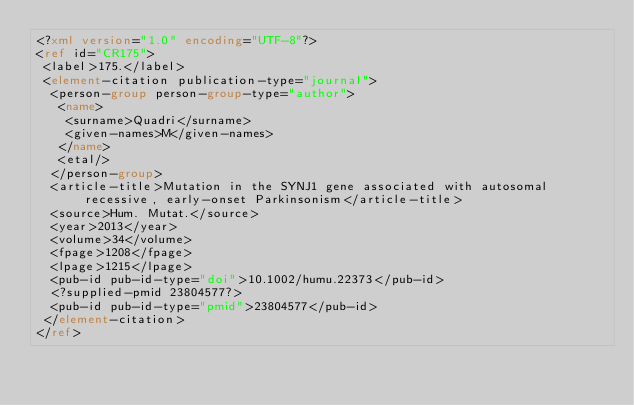Convert code to text. <code><loc_0><loc_0><loc_500><loc_500><_XML_><?xml version="1.0" encoding="UTF-8"?>
<ref id="CR175">
 <label>175.</label>
 <element-citation publication-type="journal">
  <person-group person-group-type="author">
   <name>
    <surname>Quadri</surname>
    <given-names>M</given-names>
   </name>
   <etal/>
  </person-group>
  <article-title>Mutation in the SYNJ1 gene associated with autosomal recessive, early-onset Parkinsonism</article-title>
  <source>Hum. Mutat.</source>
  <year>2013</year>
  <volume>34</volume>
  <fpage>1208</fpage>
  <lpage>1215</lpage>
  <pub-id pub-id-type="doi">10.1002/humu.22373</pub-id>
  <?supplied-pmid 23804577?>
  <pub-id pub-id-type="pmid">23804577</pub-id>
 </element-citation>
</ref>
</code> 